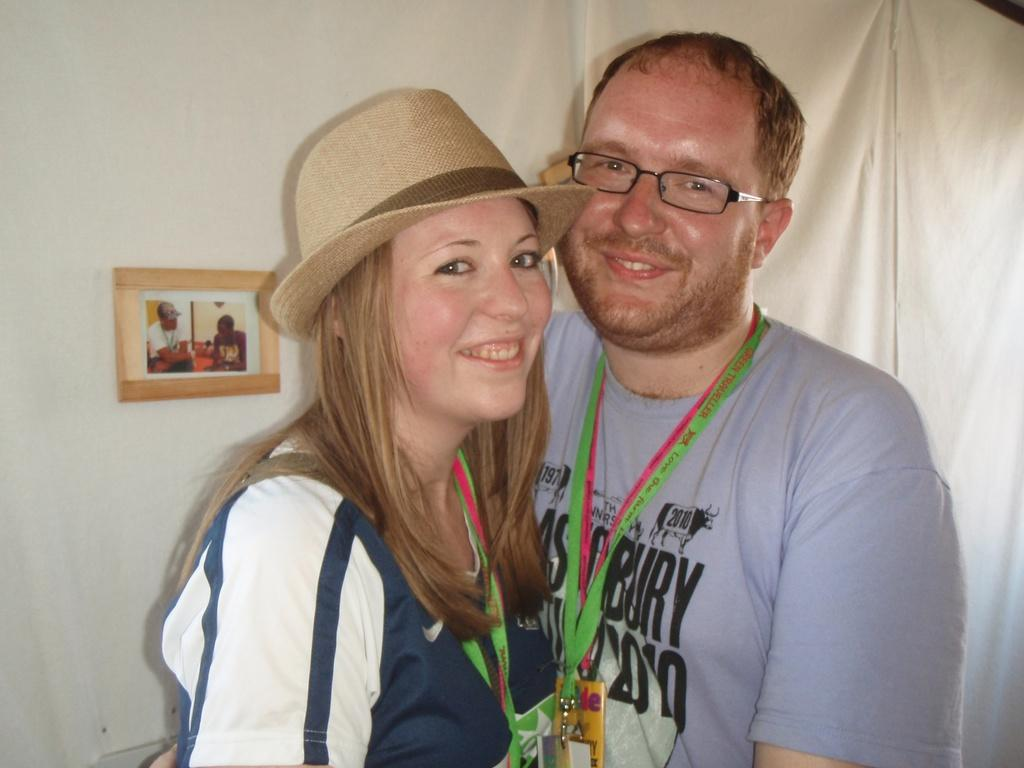What can be seen in the foreground of the image? There are persons standing in the front of the image. What is the facial expression of the persons in the image? The persons are smiling. What is present on the wall in the background of the image? There is a frame on the wall in the background of the image. What type of window treatment is visible in the background of the image? There is a white-colored curtain in the background of the image. How many crows can be seen in the image? There are no crows present in the image. 